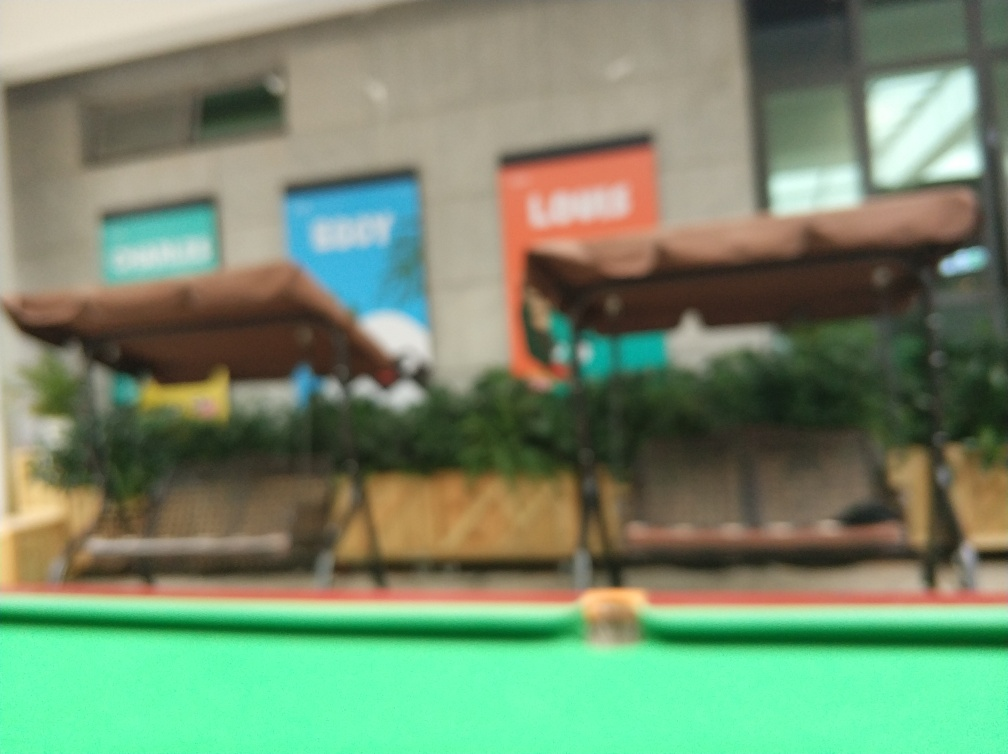What might be the reason for taking a photograph of this location? Even in its blurred state, the photograph captures the essence of a location that might hold personal significance, such as a favorite community spot or a bustling urban area. It could have been intended to capture the atmosphere, a specific event, or a memory associated with the place. The blur could be unintentional, a technical mistake, or it might have been used deliberately to evoke a sense of motion, mystery, or the passage of time. 